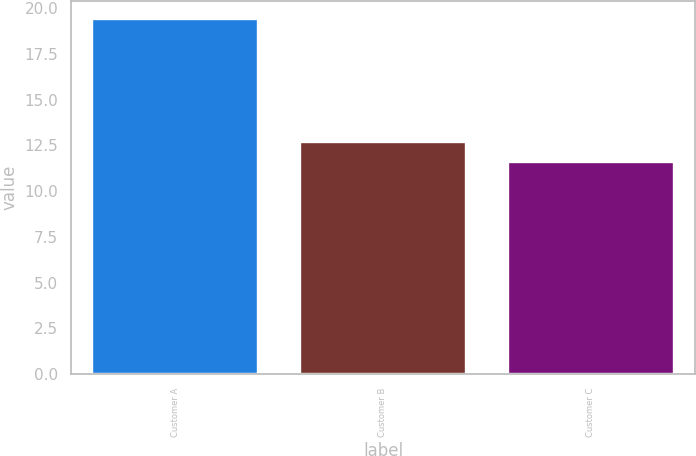Convert chart to OTSL. <chart><loc_0><loc_0><loc_500><loc_500><bar_chart><fcel>Customer A<fcel>Customer B<fcel>Customer C<nl><fcel>19.4<fcel>12.7<fcel>11.6<nl></chart> 